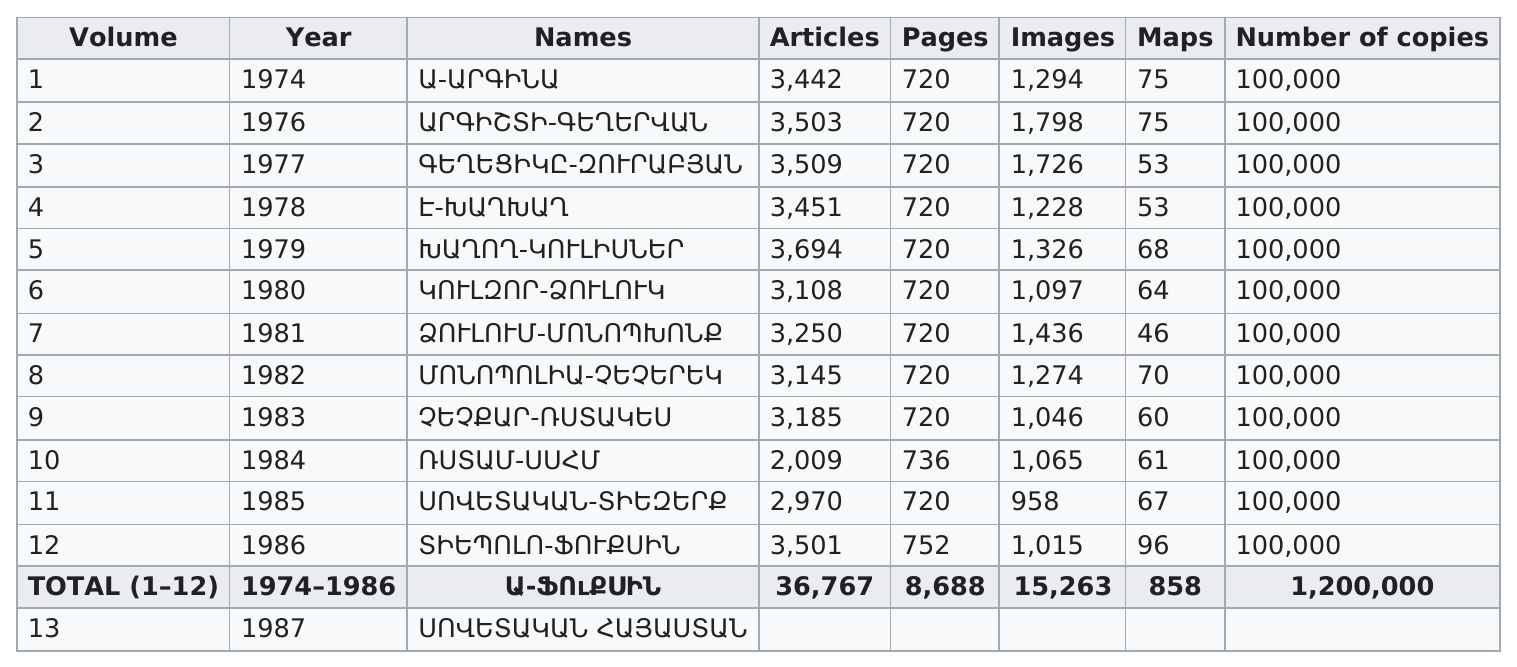Identify some key points in this picture. The difference in years between the first volume published and the 13th volume published is 13 years. Approximately 3,108 articles were published in the 6th volume. The volume that had the most maps was volume 12. The volume with the least number of images was 11. There were 36 fewer maps present in the 1986 edition compared to the 1983 edition. 